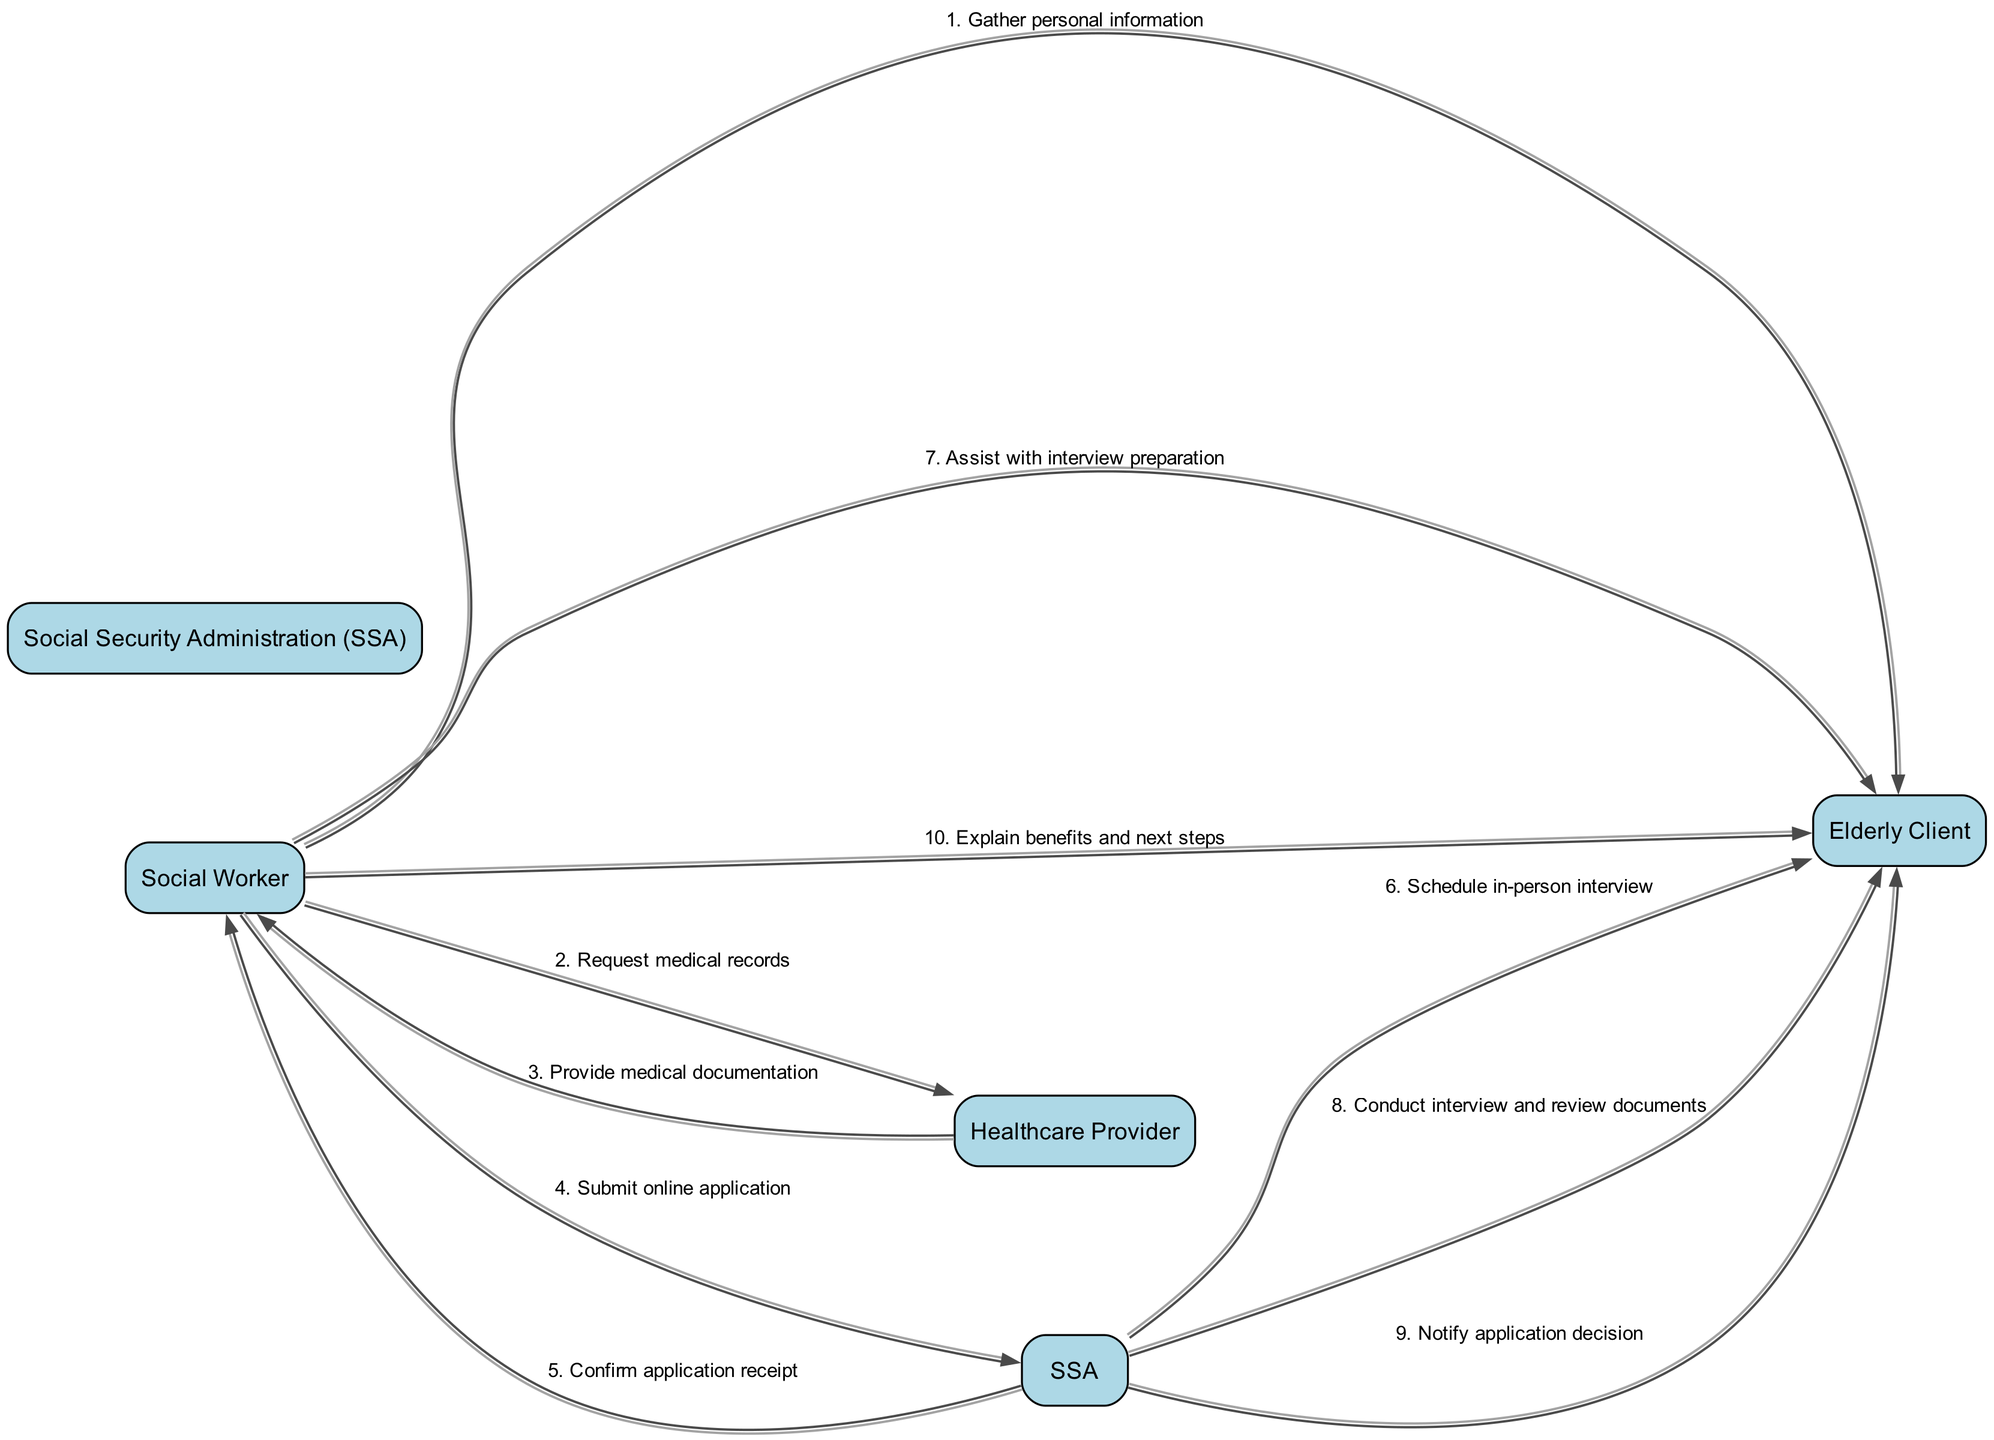What are the actors involved in the sequence diagram? The diagram lists four actors involved in the process: Social Worker, Elderly Client, Social Security Administration (SSA), and Healthcare Provider.
Answer: Social Worker, Elderly Client, Social Security Administration, Healthcare Provider How many messages are exchanged in total in the diagram? By counting the messages (edges) in the sequence, there are a total of ten messages exchanged between the actors.
Answer: 10 Who initiates the process of gathering personal information? The first message in the sequence shows that the Social Worker initiates the process by gathering personal information from the Elderly Client.
Answer: Social Worker What message does the SSA send to the Elderly Client after confirming application receipt? After the application is received, the SSA sends a message to the Elderly Client to schedule an in-person interview. This is the sixth message in the sequence.
Answer: Schedule in-person interview What is the last step the Social Worker takes after the SSA notifies the application decision? The final message in the sequence illustrates that the Social Worker explains the benefits and next steps to the Elderly Client after receiving the decision from the SSA.
Answer: Explain benefits and next steps How many actors receive messages from the SSA? By reviewing the diagram, it is clear that there are two recipients of messages from the SSA: the Elderly Client, who receives two messages, and the Social Worker, who receives one message. In total, SSA communicates with two unique actors.
Answer: 2 Which actor assists the Elderly Client with interview preparation? Referring to the fourth message in the sequence, the Social Worker is the one who assists the Elderly Client with interview preparation prior to the SSA's interview.
Answer: Social Worker What type of document does the Social Worker request from the Healthcare Provider? The second message indicates that the Social Worker requests medical records from the Healthcare Provider as part of the benefits application procedure.
Answer: Medical records What is the nature of the relationship between the Social Worker and the Elderly Client in this process? The Social Worker provides support and guidance to the Elderly Client throughout the application process, including gathering information and preparing for interviews. This indicates a supportive and advocate role of the Social Worker towards the Elderly Client.
Answer: Supportive and advocate role What is the primary purpose of the diagram? The diagram visually represents the sequence of interactions and communication steps involved in the application procedure for social security benefits specifically aimed at elderly clients.
Answer: Application procedure visualization 